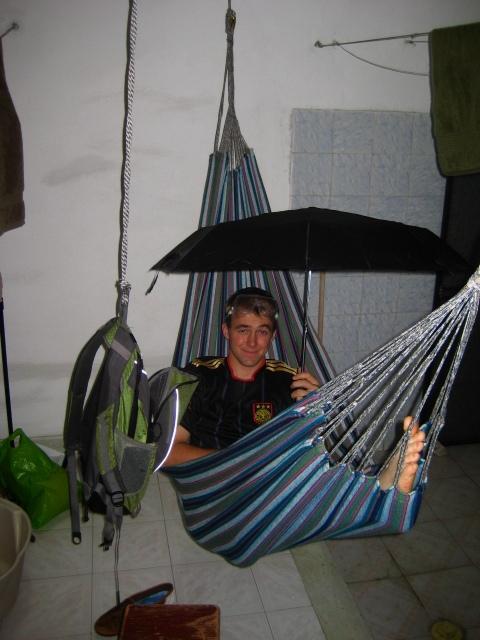Is the man wearing glasses?
Concise answer only. No. Is that a shadow where the man is?
Quick response, please. No. What is hanging by a chain?
Short answer required. Hammock. Who plays with the umbrella?
Keep it brief. Man. What kind of expression in the man wearing?
Keep it brief. Happy. Was it a sunny day when this picture was taken?
Give a very brief answer. No. What color is the hook?
Be succinct. Silver. What is the man laying in?
Concise answer only. Hammock. What color are the umbrellas?
Concise answer only. Black. Where did that brown bag come from?
Keep it brief. Store. Has anyone purchased anything in this photo?
Keep it brief. No. Is there a bed frame nearby?
Quick response, please. No. What color umbrella is he holding?
Keep it brief. Black. What is this person lying in?
Give a very brief answer. Hammock. Is it raining on the young man?
Write a very short answer. No. What is the man doing?
Concise answer only. Laying in hammock. How many people are in the photo?
Answer briefly. 1. What is the person lying on?
Be succinct. Hammock. What is on the hook?
Short answer required. Hammock. What color is the umbrella?
Write a very short answer. Black. What is the man holding?
Write a very short answer. Umbrella. Is that a natural hair color?
Be succinct. No. Is this photo colored?
Short answer required. Yes. 